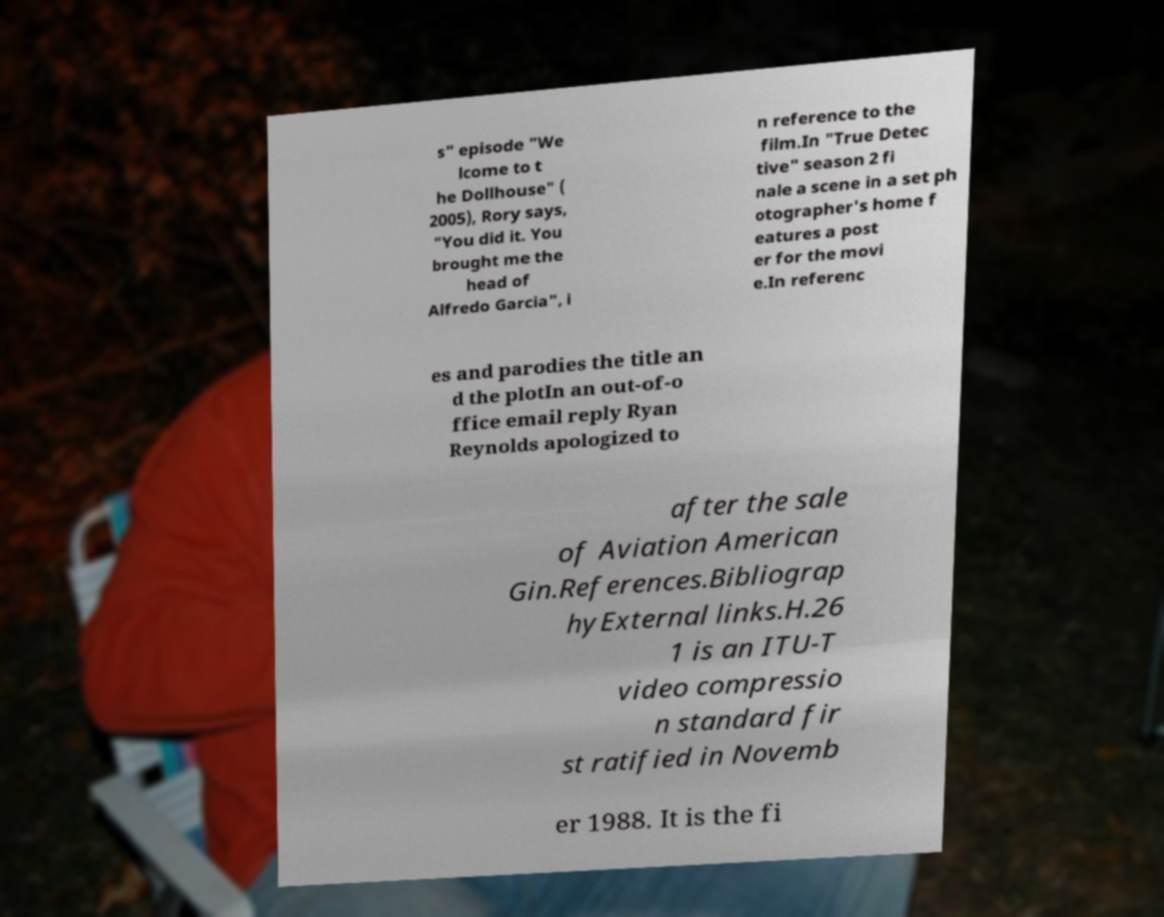For documentation purposes, I need the text within this image transcribed. Could you provide that? s" episode "We lcome to t he Dollhouse" ( 2005), Rory says, "You did it. You brought me the head of Alfredo Garcia", i n reference to the film.In "True Detec tive" season 2 fi nale a scene in a set ph otographer's home f eatures a post er for the movi e.In referenc es and parodies the title an d the plotIn an out-of-o ffice email reply Ryan Reynolds apologized to after the sale of Aviation American Gin.References.Bibliograp hyExternal links.H.26 1 is an ITU-T video compressio n standard fir st ratified in Novemb er 1988. It is the fi 